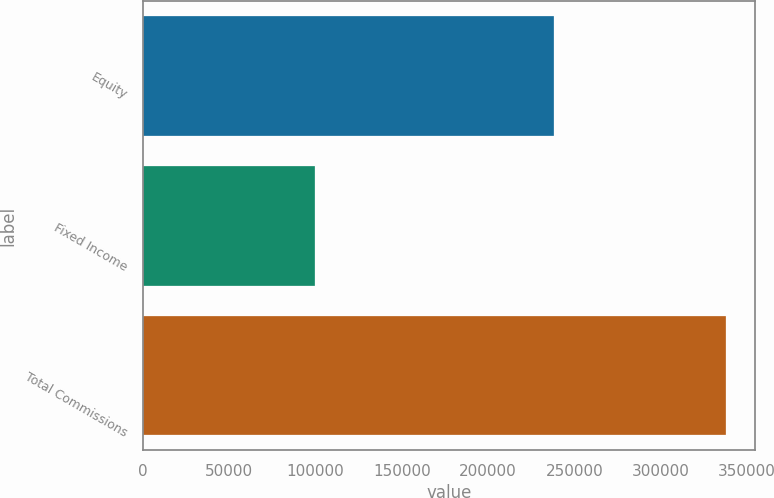Convert chart. <chart><loc_0><loc_0><loc_500><loc_500><bar_chart><fcel>Equity<fcel>Fixed Income<fcel>Total Commissions<nl><fcel>237920<fcel>99870<fcel>337790<nl></chart> 